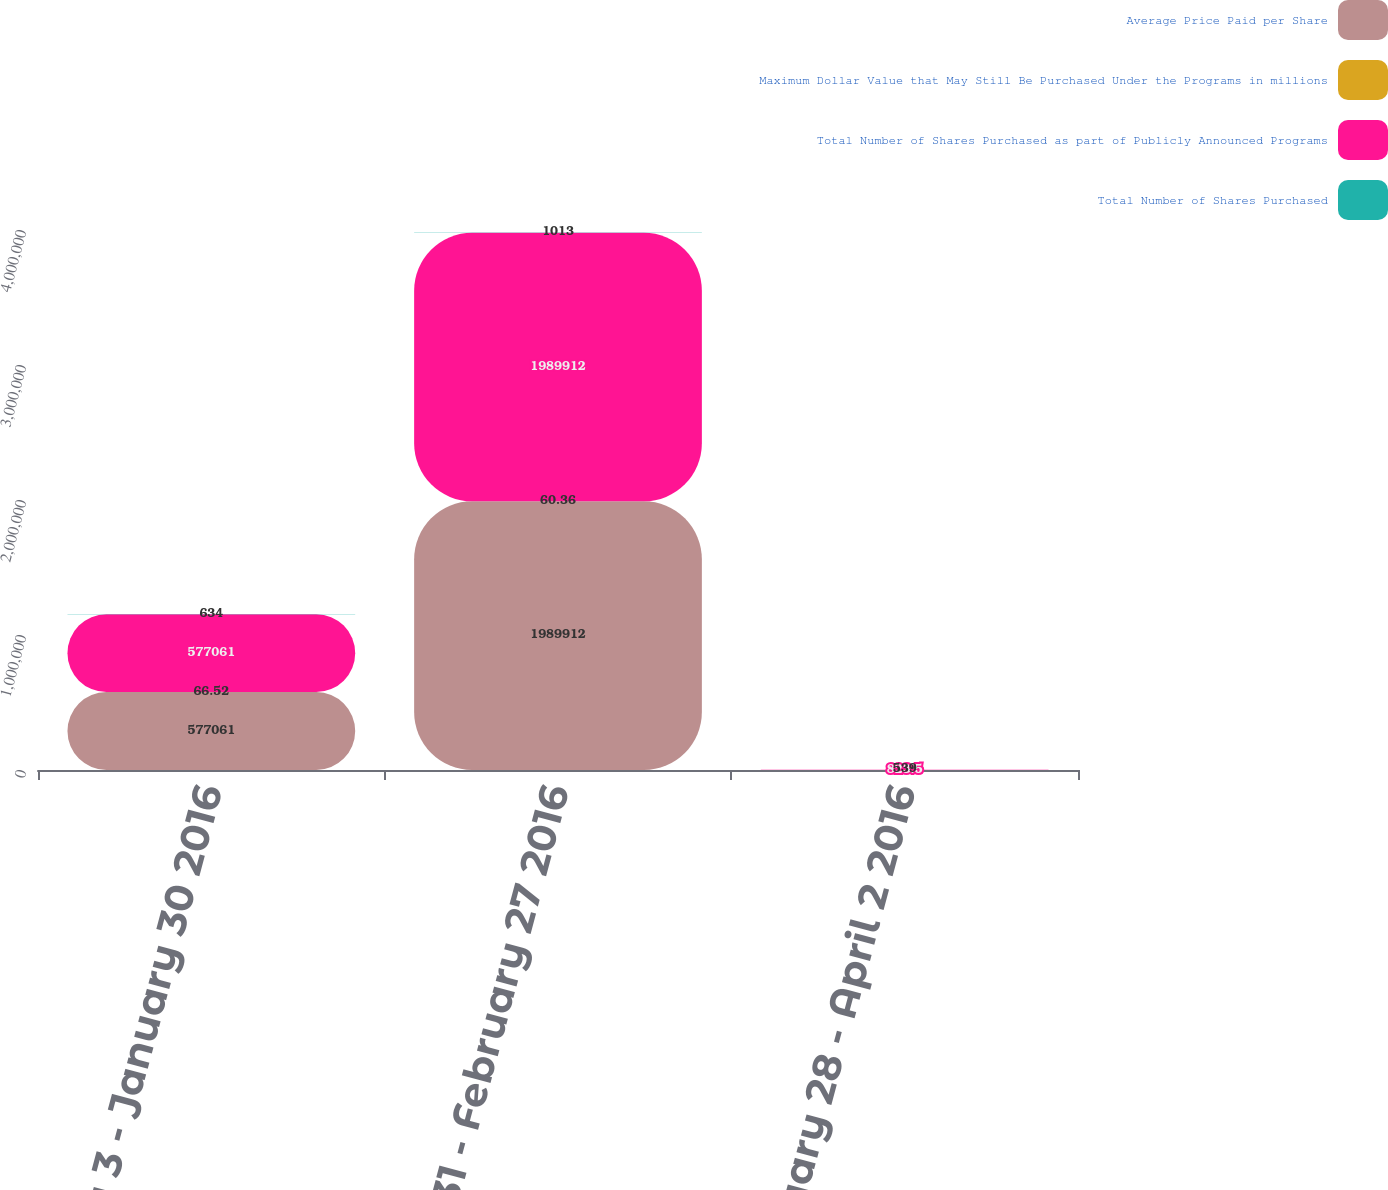Convert chart to OTSL. <chart><loc_0><loc_0><loc_500><loc_500><stacked_bar_chart><ecel><fcel>January 3 - January 30 2016<fcel>January 31 - February 27 2016<fcel>February 28 - April 2 2016<nl><fcel>Average Price Paid per Share<fcel>577061<fcel>1.98991e+06<fcel>823.5<nl><fcel>Maximum Dollar Value that May Still Be Purchased Under the Programs in millions<fcel>66.52<fcel>60.36<fcel>64.38<nl><fcel>Total Number of Shares Purchased as part of Publicly Announced Programs<fcel>577061<fcel>1.98991e+06<fcel>823.5<nl><fcel>Total Number of Shares Purchased<fcel>634<fcel>1013<fcel>539<nl></chart> 